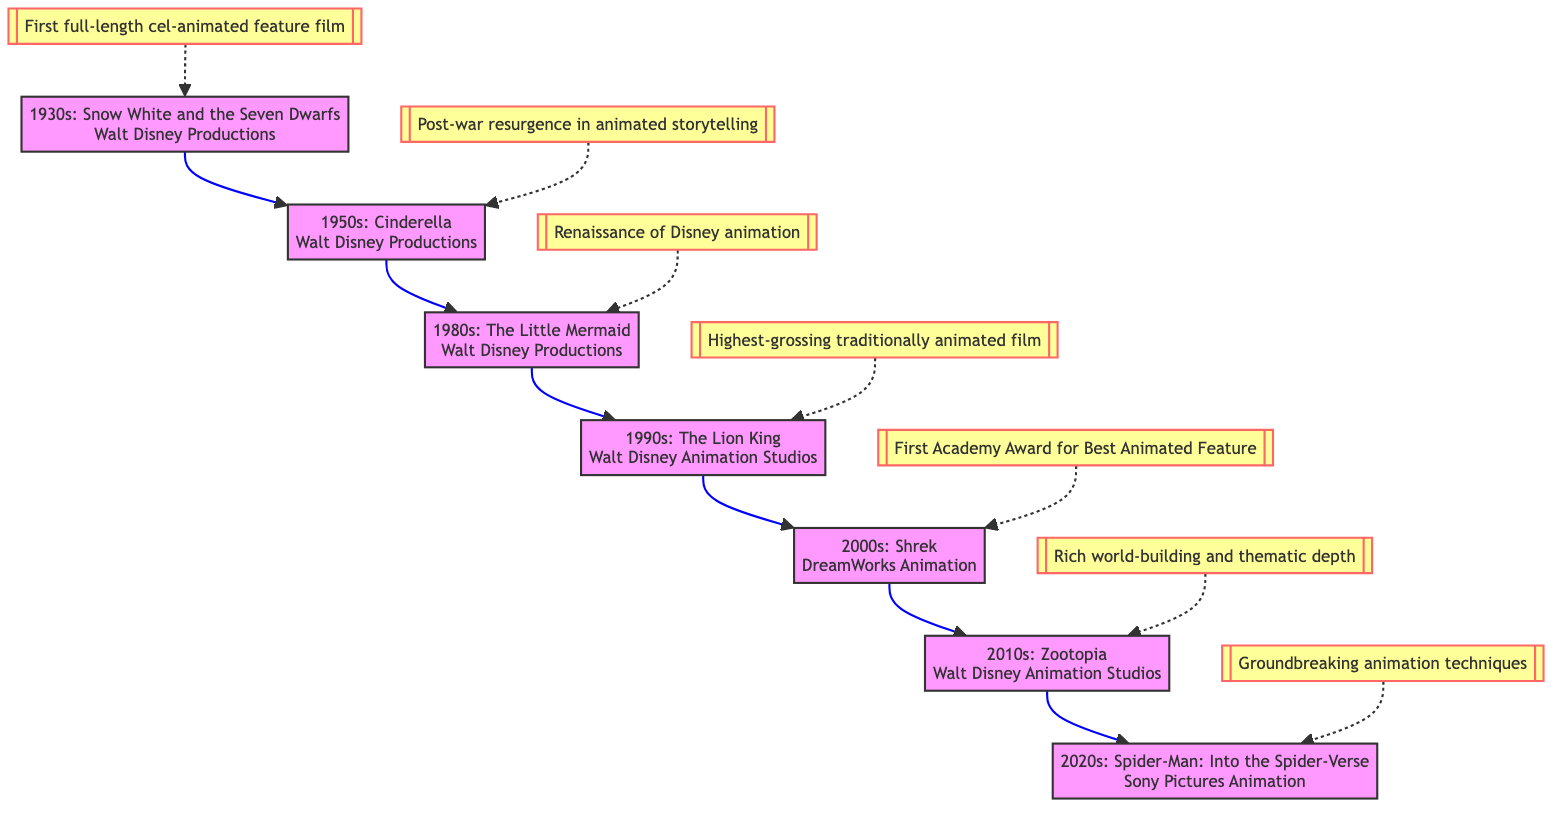What was the first full-length cel-animated feature film? The diagram indicates that "Snow White and the Seven Dwarfs" from the 1930s is marked as the first full-length cel-animated feature film. Therefore, this movie represents the starting point of animated movie milestones.
Answer: Snow White and the Seven Dwarfs Which studio produced "The Lion King"? According to the diagram, "The Lion King," released in the 1990s, is associated with Walt Disney Animation Studios. The studio is displayed next to the movie title and year.
Answer: Walt Disney Animation Studios How many decades of animated movie milestones are shown in the diagram? The diagram features milestones from the 1930s to the 2020s, which spans across seven different decades including the '30s, '50s, '80s, '90s, '00s, '10s, and '20s. By counting these distinct decades, we determine the total.
Answer: 7 What is the milestone for the 2010s? The 2010s milestone in the diagram highlights "Rich world-building and thematic depth" associated with "Zootopia." This is listed directly under the decade and movie in the vertical structure of the flowchart.
Answer: Rich world-building and thematic depth Which film marked the start of the Disney animation renaissance? The diagram states that "The Little Mermaid" from the 1980s is identified as the point of the "Renaissance of Disney animation." This answers the question by identifying the pivotal film in the timeline provided.
Answer: The Little Mermaid What are the animation techniques highlighted in the 2020s? The 2020s milestone indicates "Groundbreaking animation techniques and diverse storytelling" for "Spider-Man: Into the Spider-Verse." The details are directly connected to the decade and film in the diagram.
Answer: Groundbreaking animation techniques What decade is associated with the first Academy Award for Best Animated Feature? The diagram shows that the 2000s, with "Shrek" as the notable film, corresponds to the first Academy Award for Best Animated Feature. This distinctive connection identifies the specific year range mentioned.
Answer: 2000s Which movie is cited as the highest-grossing traditionally animated film? According to the diagram, "The Lion King" from the 1990s is specifically cited as the highest-grossing traditionally animated film, making it a key milestone in the growth of animated movies.
Answer: The Lion King What is the milestone described for the 1950s? The diagram points out that the milestone for the 1950s is "Post-war resurgence in animated storytelling" related to the film "Cinderella." This highlights the particular context of animated films during that decade.
Answer: Post-war resurgence in animated storytelling 